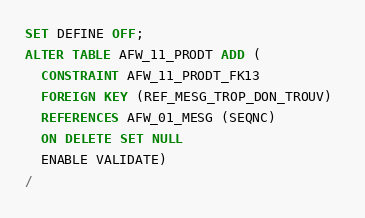<code> <loc_0><loc_0><loc_500><loc_500><_SQL_>SET DEFINE OFF;
ALTER TABLE AFW_11_PRODT ADD (
  CONSTRAINT AFW_11_PRODT_FK13 
  FOREIGN KEY (REF_MESG_TROP_DON_TROUV) 
  REFERENCES AFW_01_MESG (SEQNC)
  ON DELETE SET NULL
  ENABLE VALIDATE)
/
</code> 